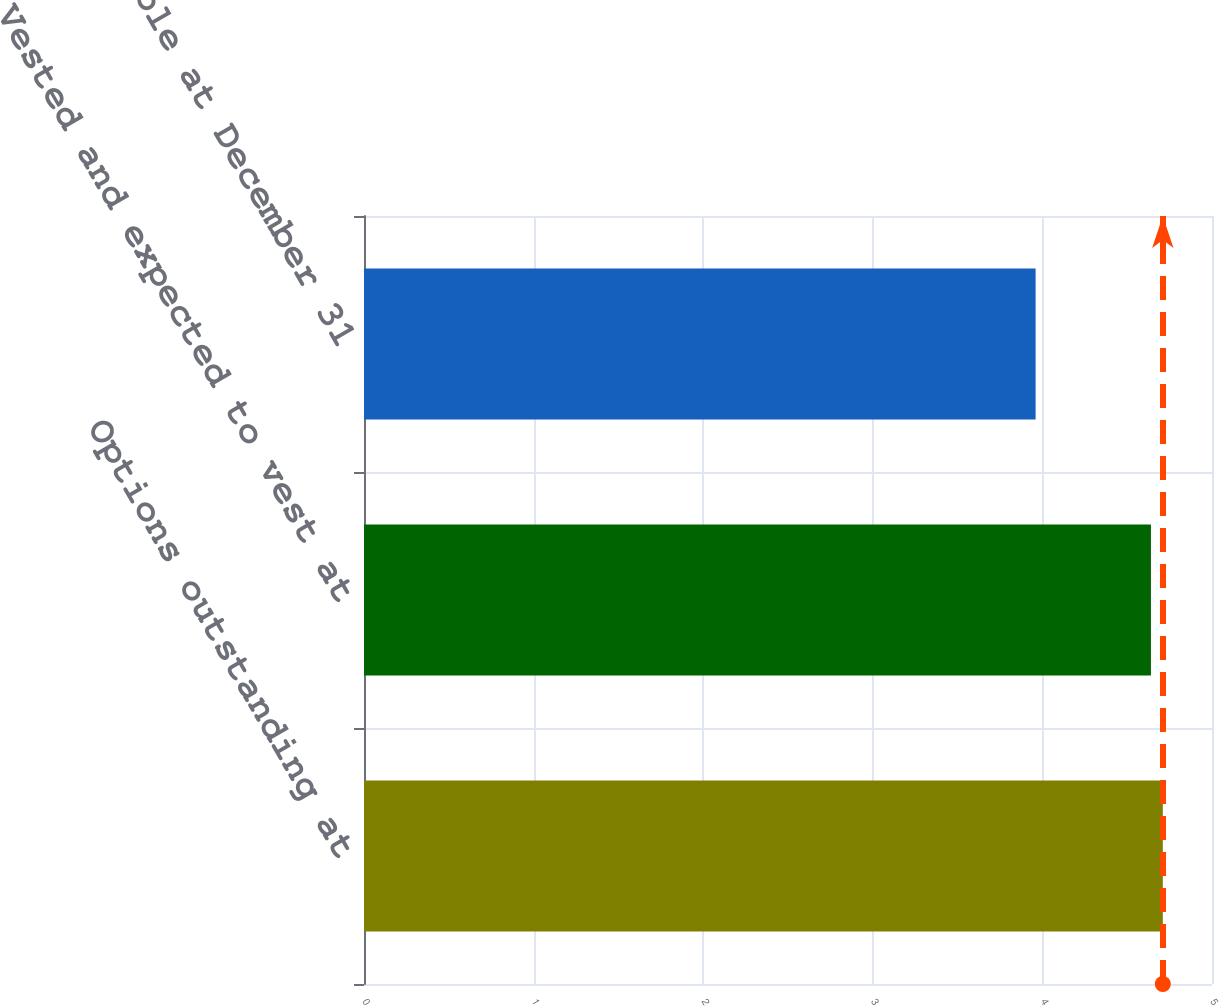Convert chart. <chart><loc_0><loc_0><loc_500><loc_500><bar_chart><fcel>Options outstanding at<fcel>Vested and expected to vest at<fcel>Exercisable at December 31<nl><fcel>4.71<fcel>4.64<fcel>3.96<nl></chart> 